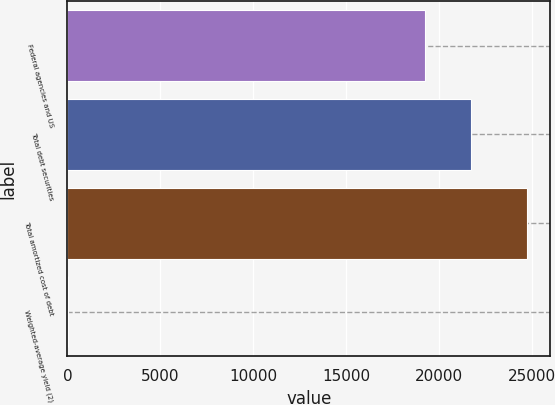<chart> <loc_0><loc_0><loc_500><loc_500><bar_chart><fcel>Federal agencies and US<fcel>Total debt securities<fcel>Total amortized cost of debt<fcel>Weighted-average yield (2)<nl><fcel>19231<fcel>21707.5<fcel>24767<fcel>2.49<nl></chart> 